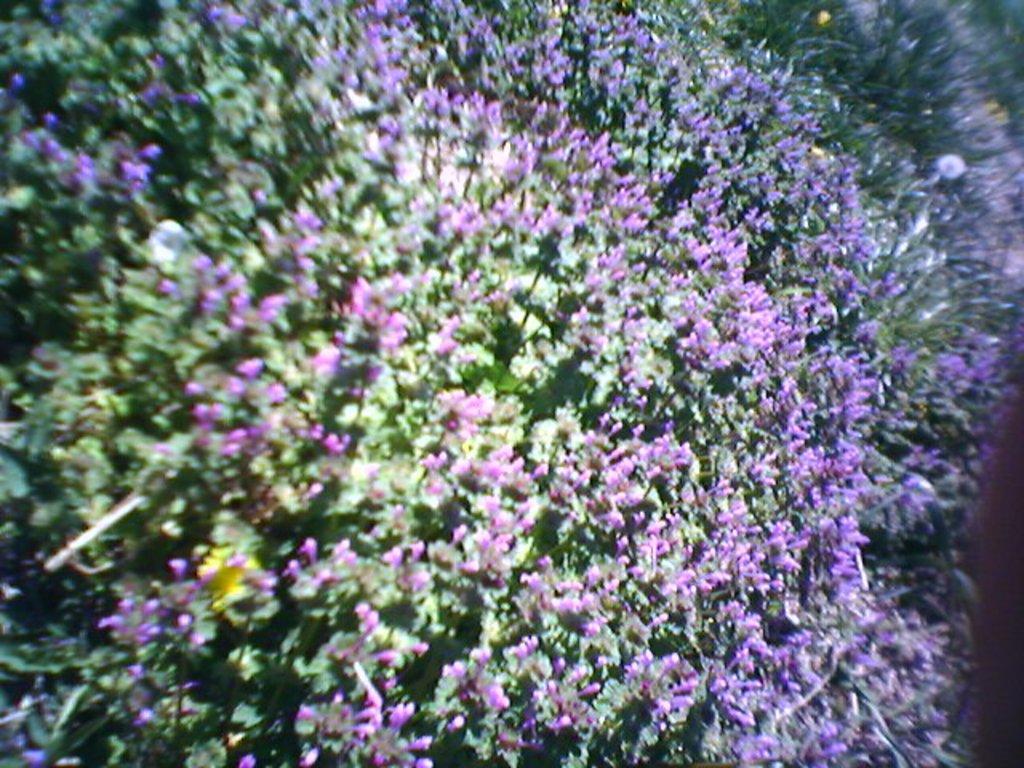Please provide a concise description of this image. These are the flower plants. 